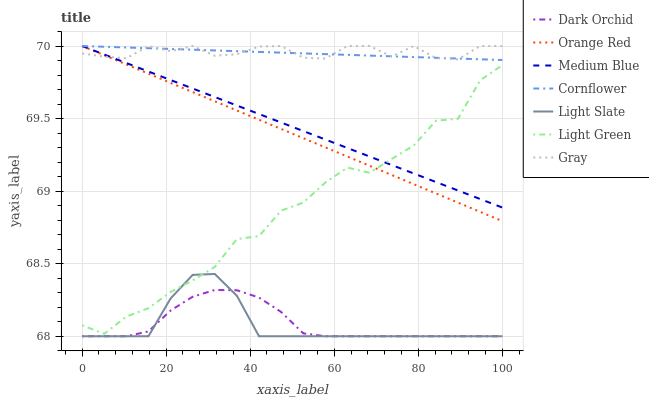Does Light Slate have the minimum area under the curve?
Answer yes or no. Yes. Does Gray have the maximum area under the curve?
Answer yes or no. Yes. Does Gray have the minimum area under the curve?
Answer yes or no. No. Does Light Slate have the maximum area under the curve?
Answer yes or no. No. Is Cornflower the smoothest?
Answer yes or no. Yes. Is Light Green the roughest?
Answer yes or no. Yes. Is Gray the smoothest?
Answer yes or no. No. Is Gray the roughest?
Answer yes or no. No. Does Light Slate have the lowest value?
Answer yes or no. Yes. Does Gray have the lowest value?
Answer yes or no. No. Does Orange Red have the highest value?
Answer yes or no. Yes. Does Light Slate have the highest value?
Answer yes or no. No. Is Light Slate less than Orange Red?
Answer yes or no. Yes. Is Medium Blue greater than Dark Orchid?
Answer yes or no. Yes. Does Orange Red intersect Medium Blue?
Answer yes or no. Yes. Is Orange Red less than Medium Blue?
Answer yes or no. No. Is Orange Red greater than Medium Blue?
Answer yes or no. No. Does Light Slate intersect Orange Red?
Answer yes or no. No. 